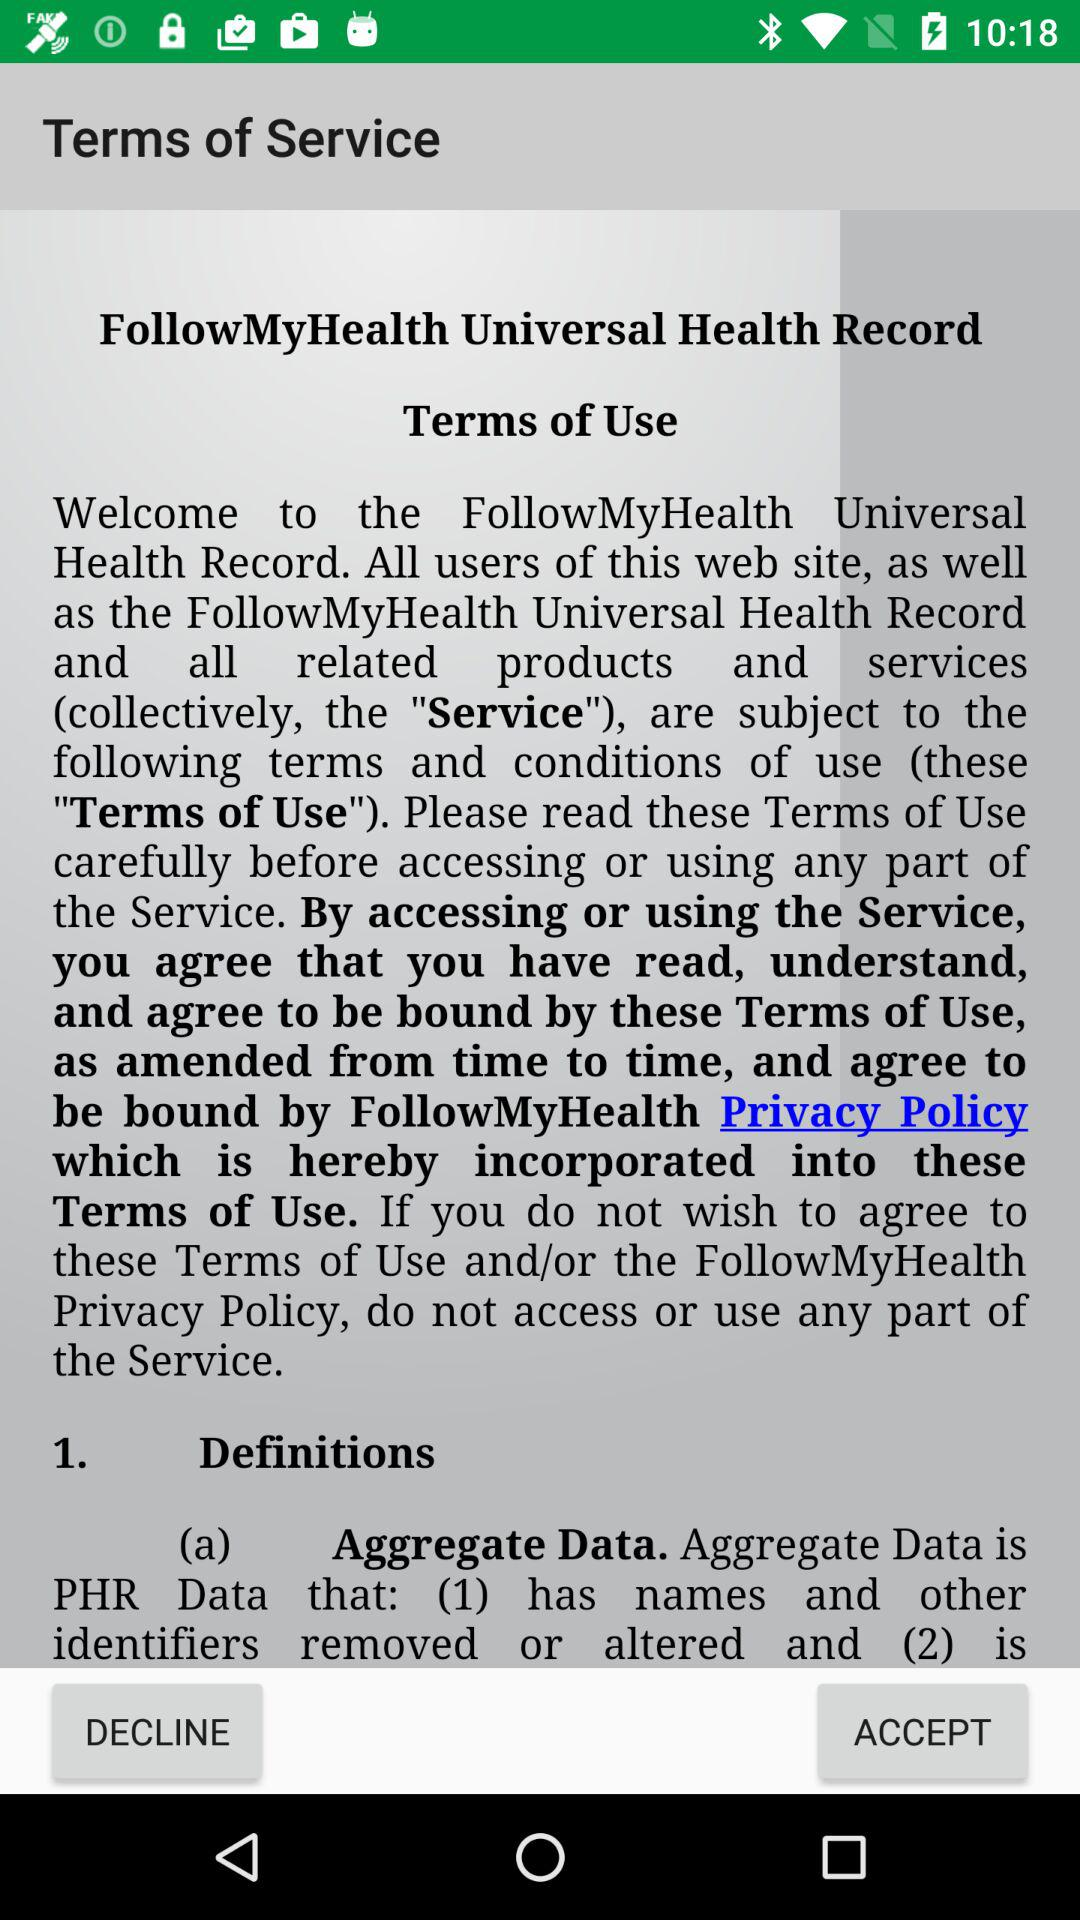How to fallow my health universal heath record?
When the provided information is insufficient, respond with <no answer>. <no answer> 